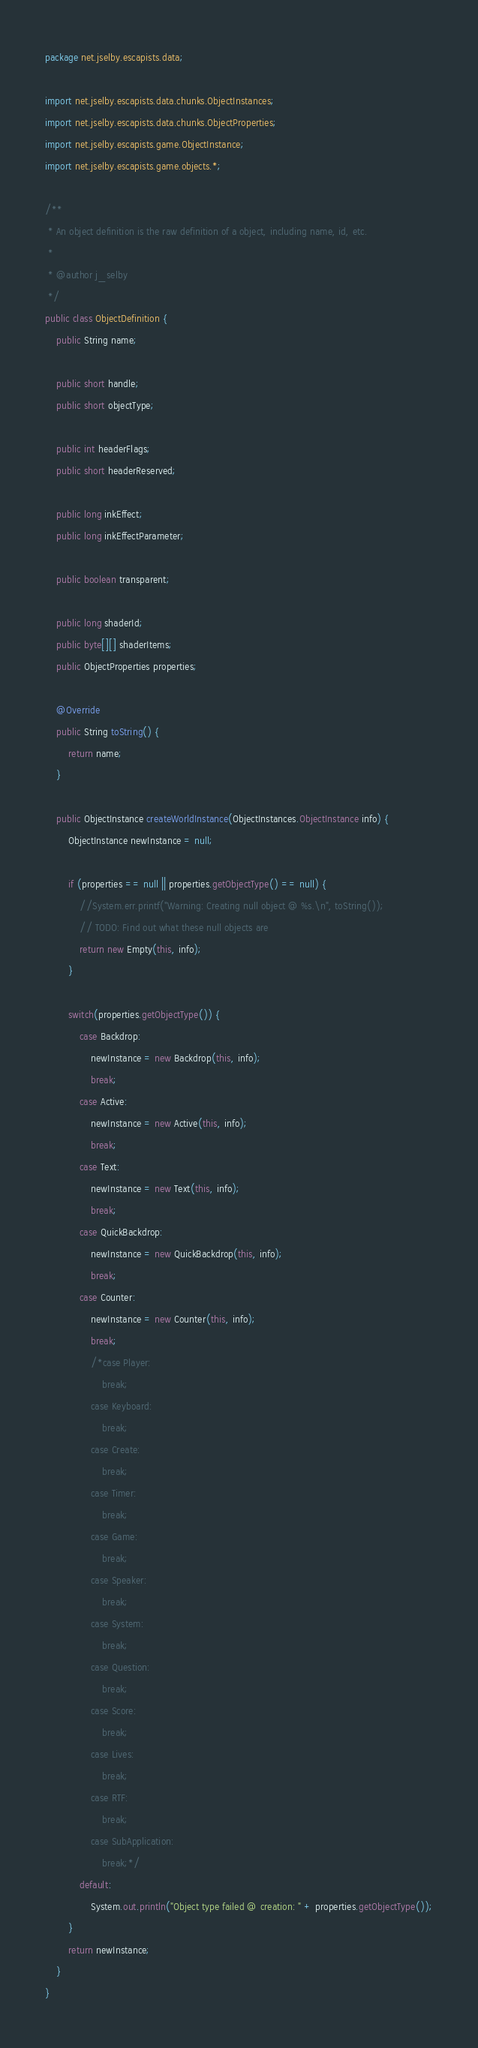Convert code to text. <code><loc_0><loc_0><loc_500><loc_500><_Java_>package net.jselby.escapists.data;

import net.jselby.escapists.data.chunks.ObjectInstances;
import net.jselby.escapists.data.chunks.ObjectProperties;
import net.jselby.escapists.game.ObjectInstance;
import net.jselby.escapists.game.objects.*;

/**
 * An object definition is the raw definition of a object, including name, id, etc.
 *
 * @author j_selby
 */
public class ObjectDefinition {
    public String name;

    public short handle;
    public short objectType;

    public int headerFlags;
    public short headerReserved;

    public long inkEffect;
    public long inkEffectParameter;

    public boolean transparent;

    public long shaderId;
    public byte[][] shaderItems;
    public ObjectProperties properties;

    @Override
    public String toString() {
        return name;
    }

    public ObjectInstance createWorldInstance(ObjectInstances.ObjectInstance info) {
        ObjectInstance newInstance = null;

        if (properties == null || properties.getObjectType() == null) {
            //System.err.printf("Warning: Creating null object @ %s.\n", toString());
            // TODO: Find out what these null objects are
            return new Empty(this, info);
        }

        switch(properties.getObjectType()) {
            case Backdrop:
                newInstance = new Backdrop(this, info);
                break;
            case Active:
                newInstance = new Active(this, info);
                break;
            case Text:
                newInstance = new Text(this, info);
                break;
            case QuickBackdrop:
                newInstance = new QuickBackdrop(this, info);
                break;
            case Counter:
                newInstance = new Counter(this, info);
                break;
                /*case Player:
                    break;
                case Keyboard:
                    break;
                case Create:
                    break;
                case Timer:
                    break;
                case Game:
                    break;
                case Speaker:
                    break;
                case System:
                    break;
                case Question:
                    break;
                case Score:
                    break;
                case Lives:
                    break;
                case RTF:
                    break;
                case SubApplication:
                    break;*/
            default:
                System.out.println("Object type failed @ creation: " + properties.getObjectType());
        }
        return newInstance;
    }
}
</code> 